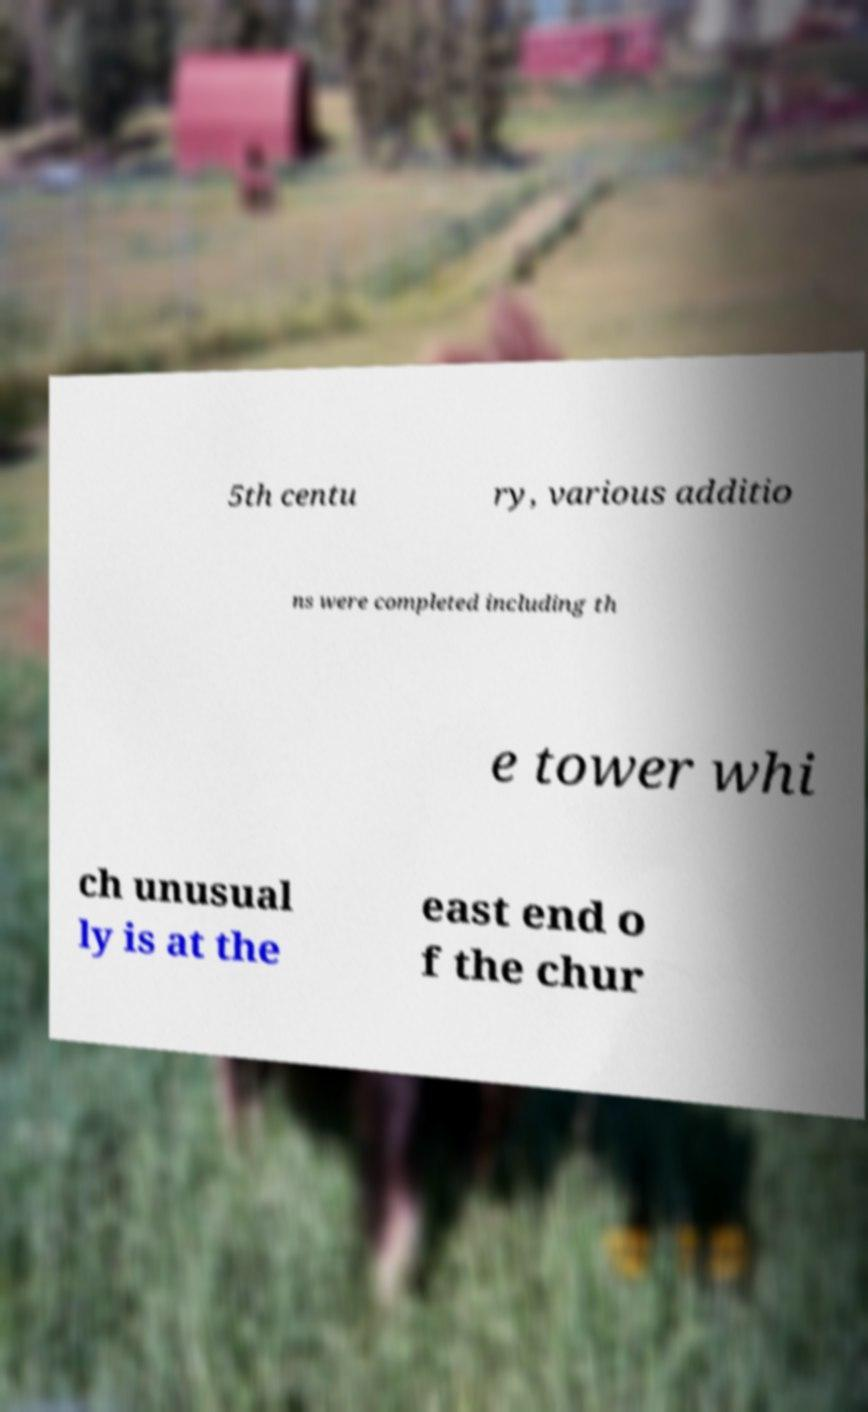Can you accurately transcribe the text from the provided image for me? 5th centu ry, various additio ns were completed including th e tower whi ch unusual ly is at the east end o f the chur 